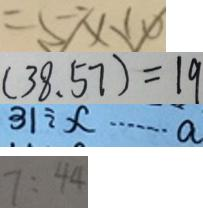Convert formula to latex. <formula><loc_0><loc_0><loc_500><loc_500>= 5 \times 1 0 
 ( 3 8 , 5 7 ) = 1 9 
 3 1 \div x \cdots a 
 7 : 4 4</formula> 